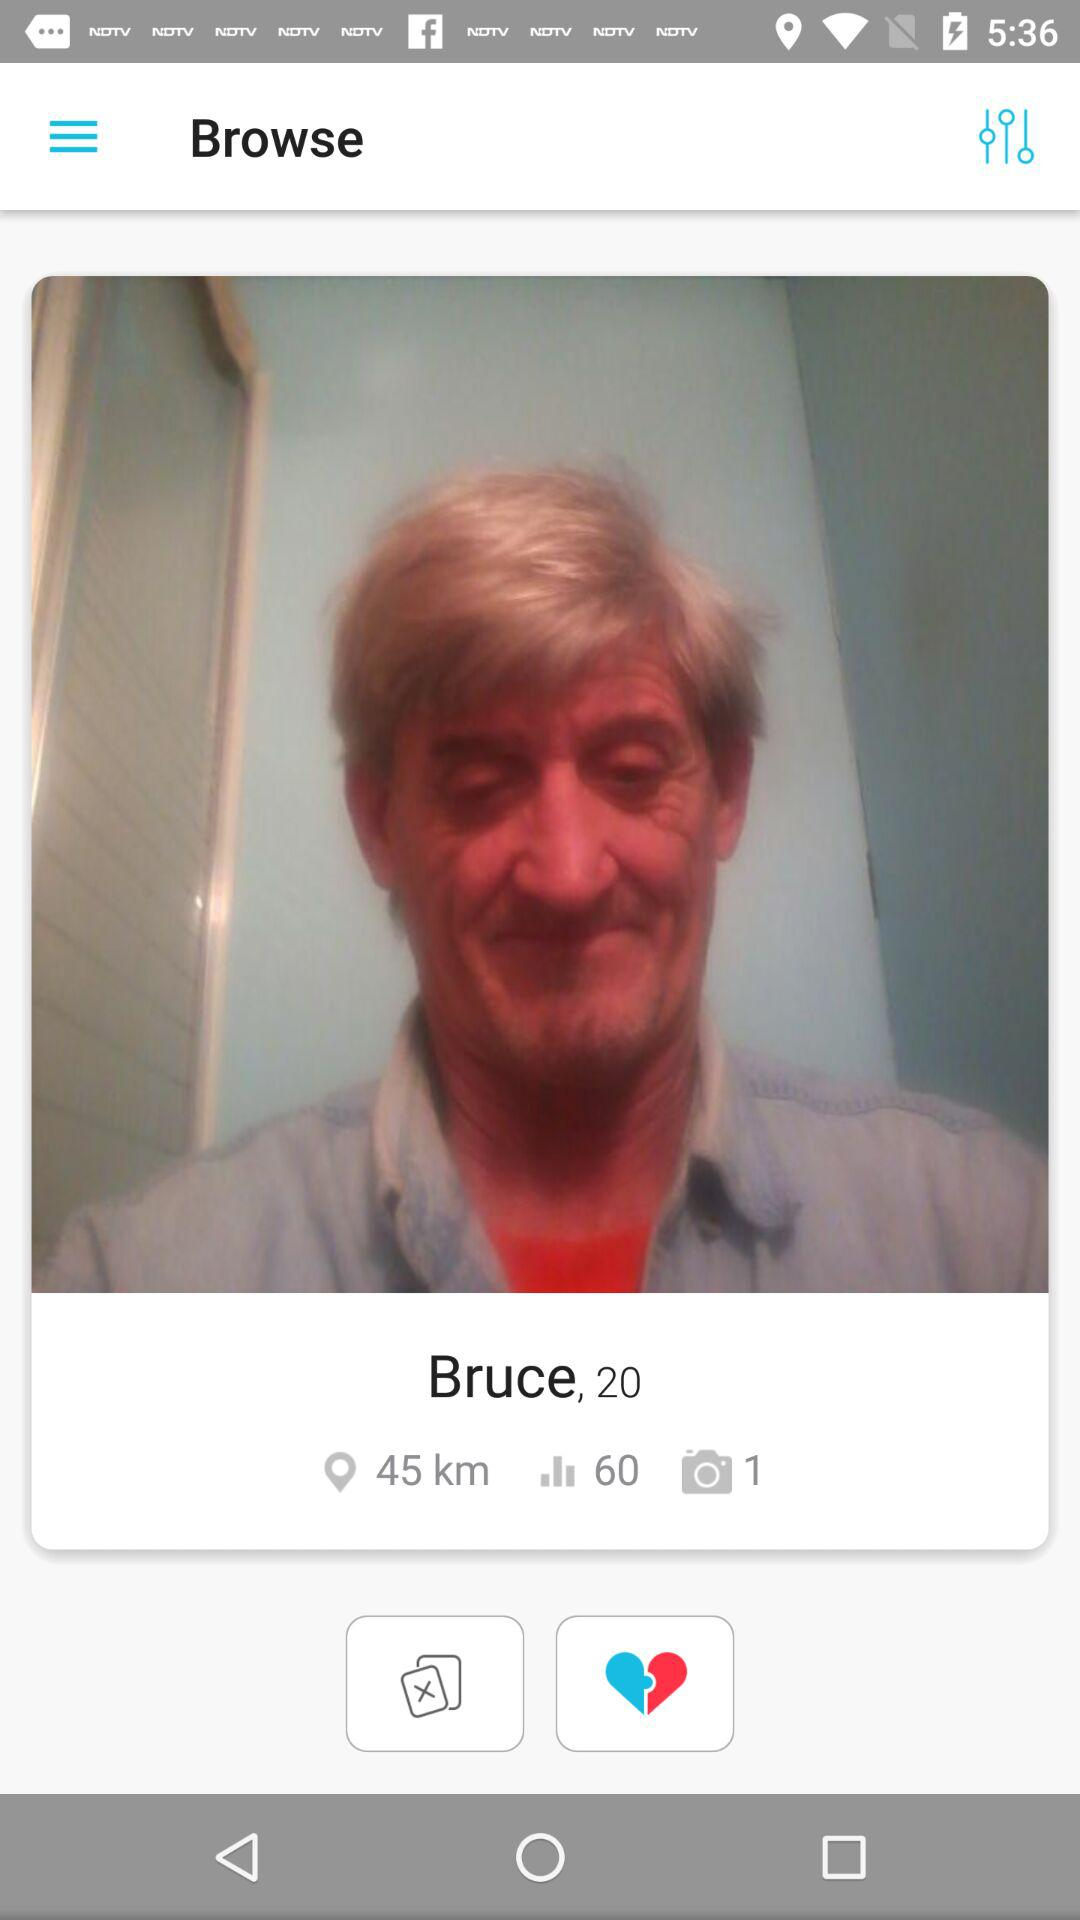How many kilometres are shown on the screen? The kilometres shown on the screen are 45. 